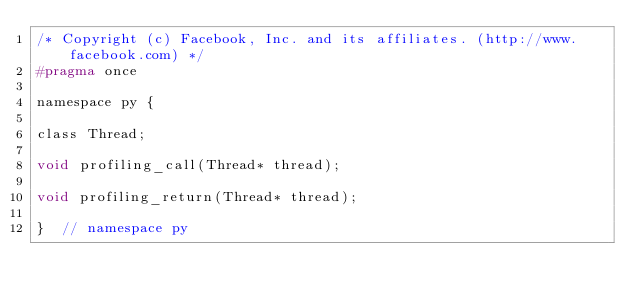<code> <loc_0><loc_0><loc_500><loc_500><_C_>/* Copyright (c) Facebook, Inc. and its affiliates. (http://www.facebook.com) */
#pragma once

namespace py {

class Thread;

void profiling_call(Thread* thread);

void profiling_return(Thread* thread);

}  // namespace py
</code> 